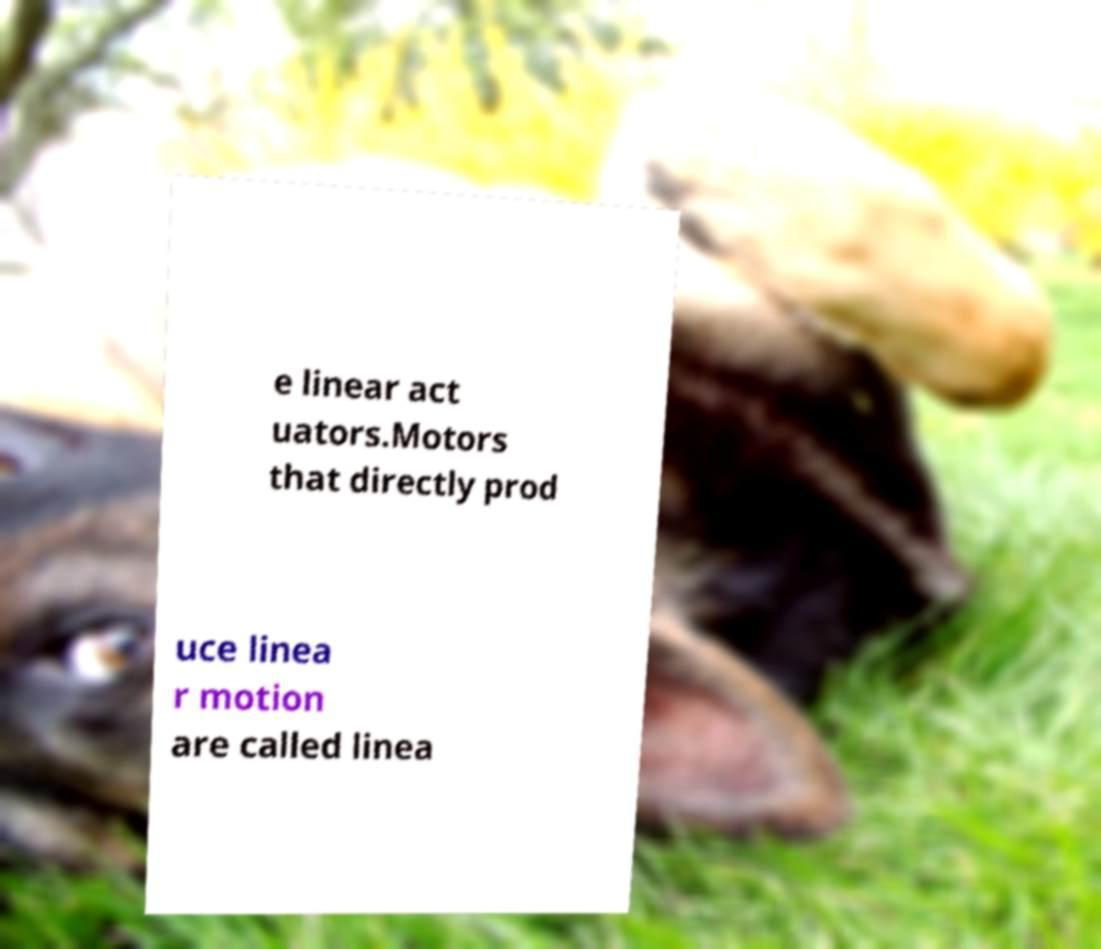What messages or text are displayed in this image? I need them in a readable, typed format. e linear act uators.Motors that directly prod uce linea r motion are called linea 